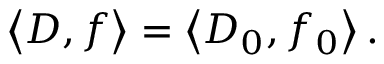Convert formula to latex. <formula><loc_0><loc_0><loc_500><loc_500>\left \langle D , f \right \rangle = \left \langle D _ { 0 } , f _ { 0 } \right \rangle .</formula> 